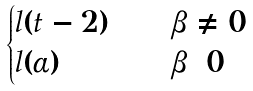Convert formula to latex. <formula><loc_0><loc_0><loc_500><loc_500>\begin{cases} l ( t - 2 ) \quad & \beta \neq 0 \\ l ( \alpha ) \quad & \beta = 0 \end{cases}</formula> 